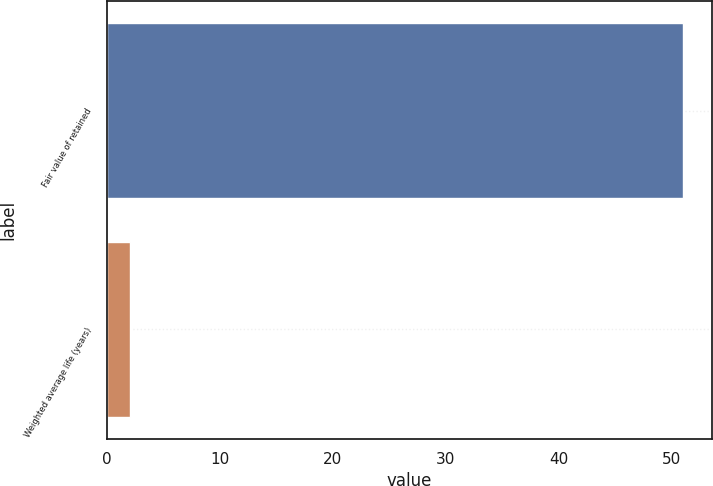<chart> <loc_0><loc_0><loc_500><loc_500><bar_chart><fcel>Fair value of retained<fcel>Weighted average life (years)<nl><fcel>51<fcel>2<nl></chart> 